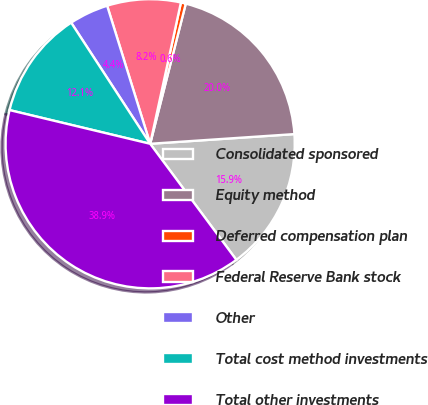Convert chart to OTSL. <chart><loc_0><loc_0><loc_500><loc_500><pie_chart><fcel>Consolidated sponsored<fcel>Equity method<fcel>Deferred compensation plan<fcel>Federal Reserve Bank stock<fcel>Other<fcel>Total cost method investments<fcel>Total other investments<nl><fcel>15.9%<fcel>19.97%<fcel>0.55%<fcel>8.22%<fcel>4.39%<fcel>12.06%<fcel>38.91%<nl></chart> 